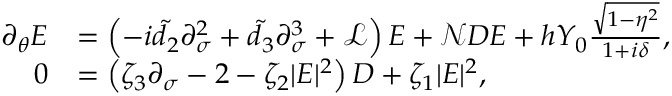<formula> <loc_0><loc_0><loc_500><loc_500>\begin{array} { r l } { \partial _ { \theta } E } & { = \left ( - i \tilde { d } _ { 2 } \partial _ { \sigma } ^ { 2 } + \tilde { d } _ { 3 } \partial _ { \sigma } ^ { 3 } + \mathcal { L } \right ) E + \mathcal { N } D E + h Y _ { 0 } \frac { \sqrt { 1 - \eta ^ { 2 } } } { 1 + i \delta } , } \\ { 0 } & { = \left ( \zeta _ { 3 } \partial _ { \sigma } - 2 - \zeta _ { 2 } | E | ^ { 2 } \right ) D + \zeta _ { 1 } | E | ^ { 2 } , } \end{array}</formula> 